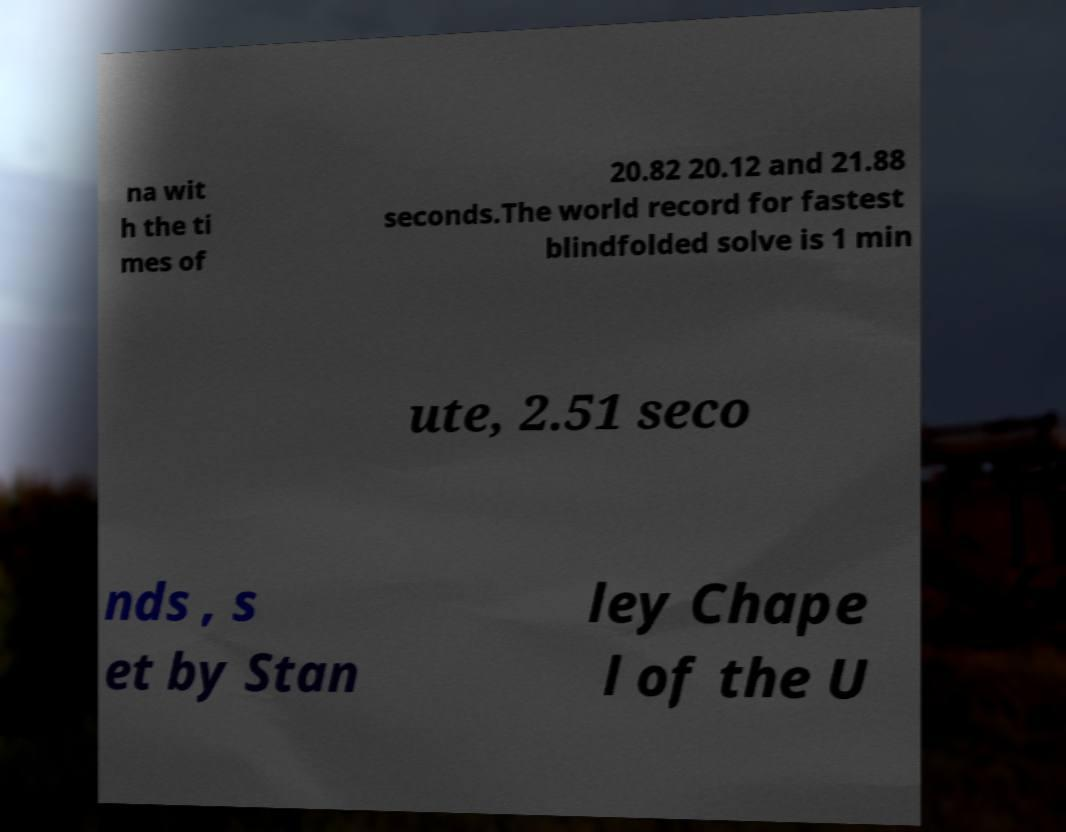Could you assist in decoding the text presented in this image and type it out clearly? na wit h the ti mes of 20.82 20.12 and 21.88 seconds.The world record for fastest blindfolded solve is 1 min ute, 2.51 seco nds , s et by Stan ley Chape l of the U 